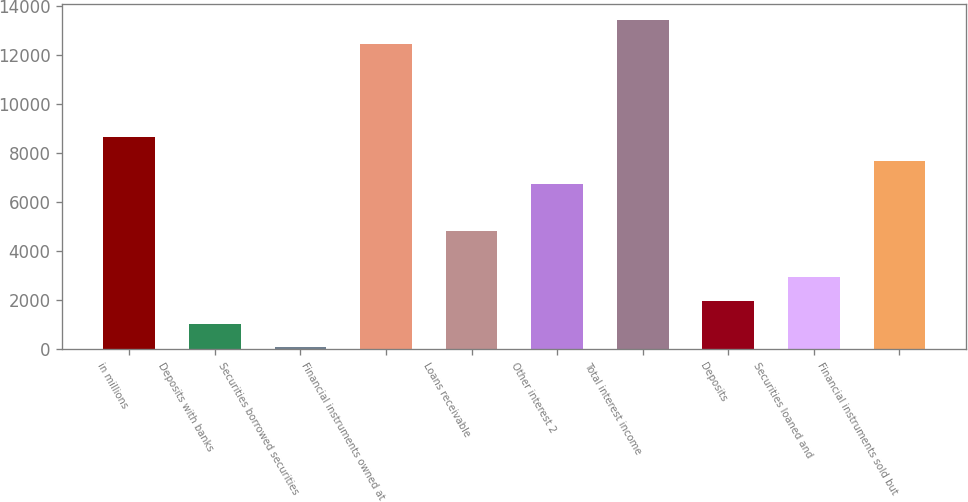Convert chart. <chart><loc_0><loc_0><loc_500><loc_500><bar_chart><fcel>in millions<fcel>Deposits with banks<fcel>Securities borrowed securities<fcel>Financial instruments owned at<fcel>Loans receivable<fcel>Other interest 2<fcel>Total interest income<fcel>Deposits<fcel>Securities loaned and<fcel>Financial instruments sold but<nl><fcel>8651.7<fcel>1033.3<fcel>81<fcel>12460.9<fcel>4842.5<fcel>6747.1<fcel>13413.2<fcel>1985.6<fcel>2937.9<fcel>7699.4<nl></chart> 